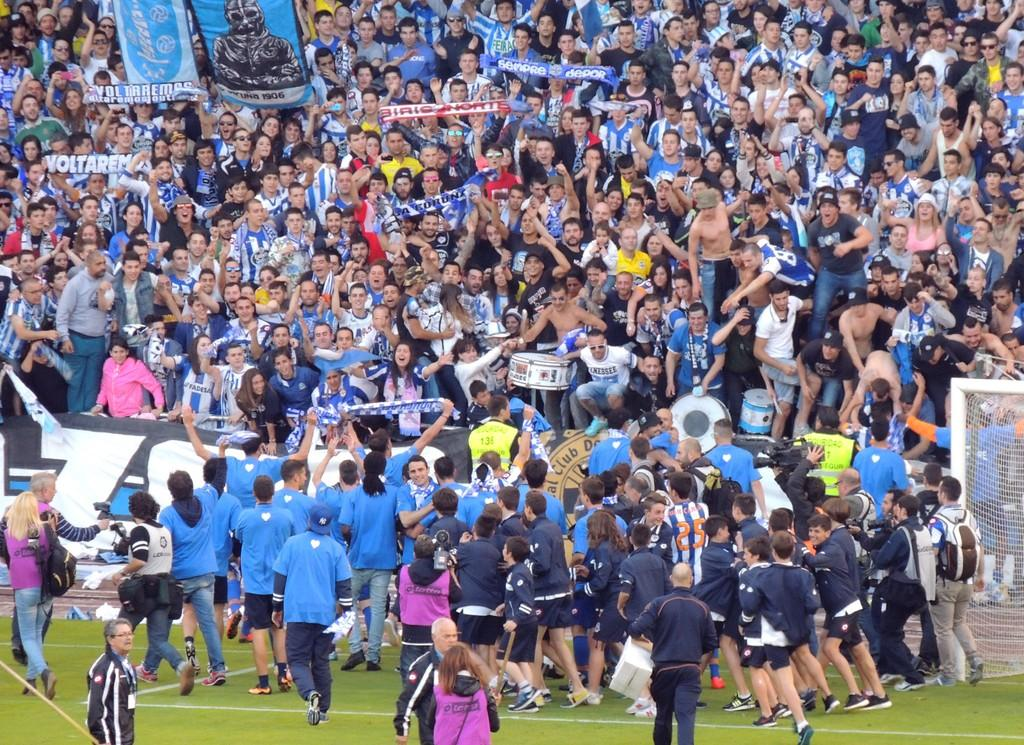Provide a one-sentence caption for the provided image. Group of people celebrating with one person holding a brown sign that says "Club". 